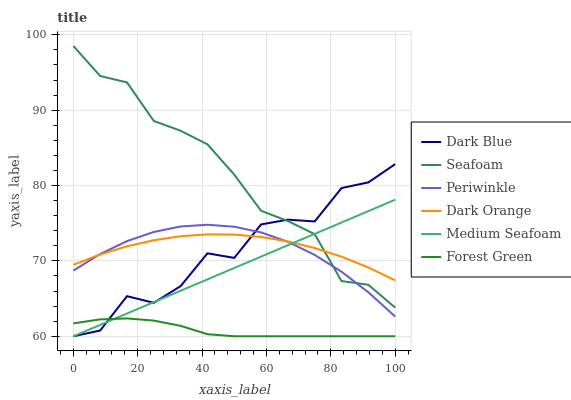Does Forest Green have the minimum area under the curve?
Answer yes or no. Yes. Does Seafoam have the maximum area under the curve?
Answer yes or no. Yes. Does Dark Blue have the minimum area under the curve?
Answer yes or no. No. Does Dark Blue have the maximum area under the curve?
Answer yes or no. No. Is Medium Seafoam the smoothest?
Answer yes or no. Yes. Is Dark Blue the roughest?
Answer yes or no. Yes. Is Seafoam the smoothest?
Answer yes or no. No. Is Seafoam the roughest?
Answer yes or no. No. Does Dark Blue have the lowest value?
Answer yes or no. Yes. Does Seafoam have the lowest value?
Answer yes or no. No. Does Seafoam have the highest value?
Answer yes or no. Yes. Does Dark Blue have the highest value?
Answer yes or no. No. Is Forest Green less than Periwinkle?
Answer yes or no. Yes. Is Periwinkle greater than Forest Green?
Answer yes or no. Yes. Does Medium Seafoam intersect Periwinkle?
Answer yes or no. Yes. Is Medium Seafoam less than Periwinkle?
Answer yes or no. No. Is Medium Seafoam greater than Periwinkle?
Answer yes or no. No. Does Forest Green intersect Periwinkle?
Answer yes or no. No. 